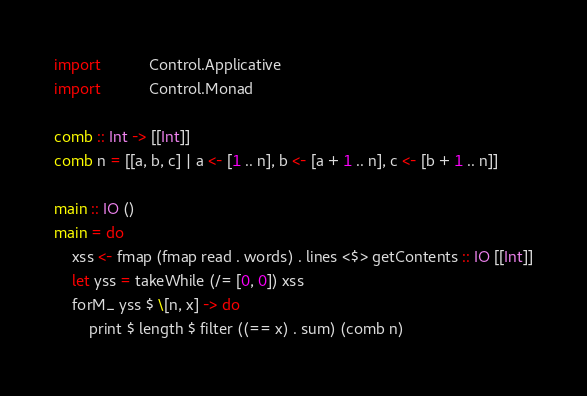Convert code to text. <code><loc_0><loc_0><loc_500><loc_500><_Haskell_>import           Control.Applicative
import           Control.Monad

comb :: Int -> [[Int]]
comb n = [[a, b, c] | a <- [1 .. n], b <- [a + 1 .. n], c <- [b + 1 .. n]]

main :: IO ()
main = do
    xss <- fmap (fmap read . words) . lines <$> getContents :: IO [[Int]]
    let yss = takeWhile (/= [0, 0]) xss
    forM_ yss $ \[n, x] -> do
        print $ length $ filter ((== x) . sum) (comb n)

</code> 